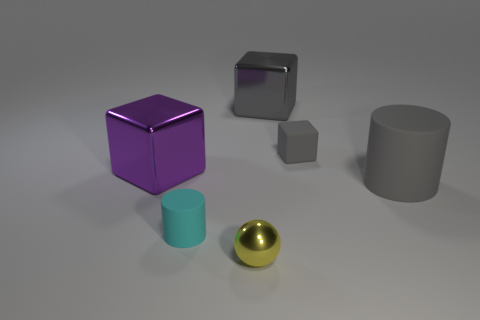Add 1 gray matte cubes. How many objects exist? 7 Subtract all spheres. How many objects are left? 5 Add 5 tiny objects. How many tiny objects exist? 8 Subtract 0 green cylinders. How many objects are left? 6 Subtract all small cyan rubber cylinders. Subtract all large cylinders. How many objects are left? 4 Add 6 shiny balls. How many shiny balls are left? 7 